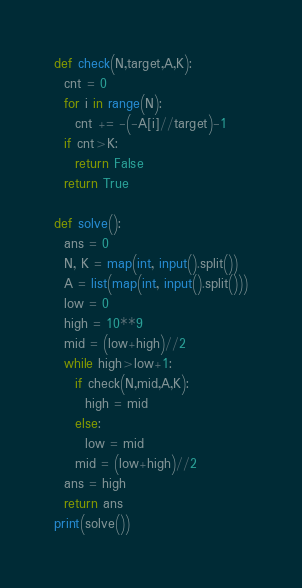<code> <loc_0><loc_0><loc_500><loc_500><_Python_>def check(N,target,A,K):
  cnt = 0
  for i in range(N):
    cnt += -(-A[i]//target)-1
  if cnt>K:
    return False
  return True

def solve():
  ans = 0
  N, K = map(int, input().split())
  A = list(map(int, input().split()))
  low = 0
  high = 10**9
  mid = (low+high)//2
  while high>low+1:
    if check(N,mid,A,K):
      high = mid
    else:
      low = mid
    mid = (low+high)//2
  ans = high
  return ans
print(solve())</code> 